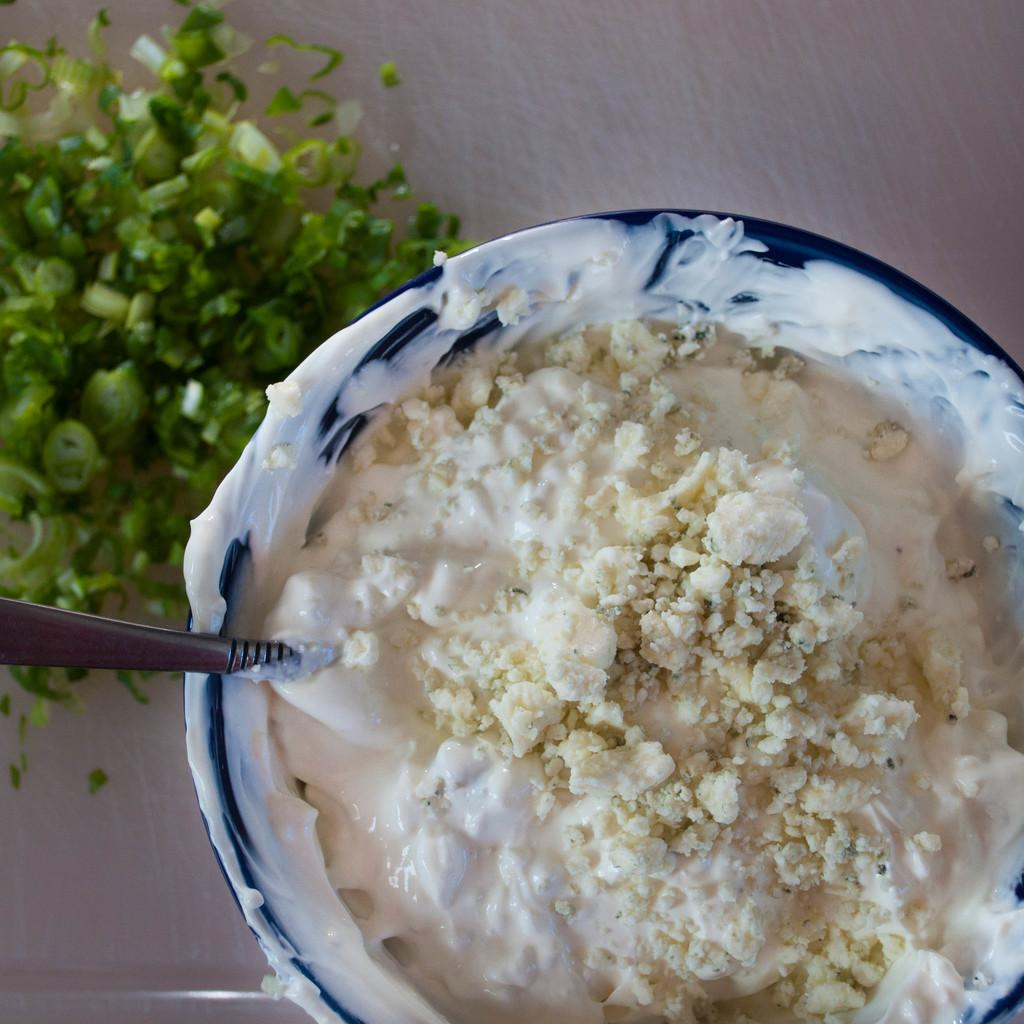What type of food can be seen in the image? There is food in the image, but the specific type cannot be determined from the provided facts. What utensil is present in the image? There is a spoon in the image. What type of food is made from plants and can be seen in the image? There are vegetables in the image. What type of spy equipment can be seen in the image? There is no spy equipment present in the image. Can you tell me where the nearest market is in the image? There is no reference to a market or its location in the image. What is the moon's phase in the image? The moon is not visible in the image. 